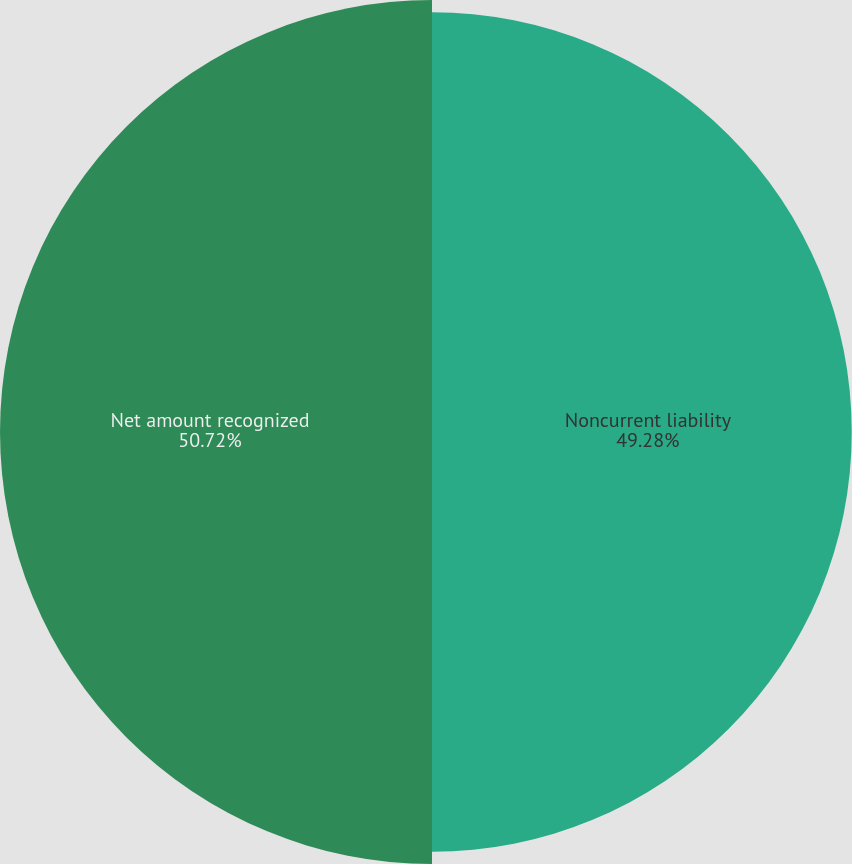Convert chart. <chart><loc_0><loc_0><loc_500><loc_500><pie_chart><fcel>Noncurrent liability<fcel>Net amount recognized<nl><fcel>49.28%<fcel>50.72%<nl></chart> 